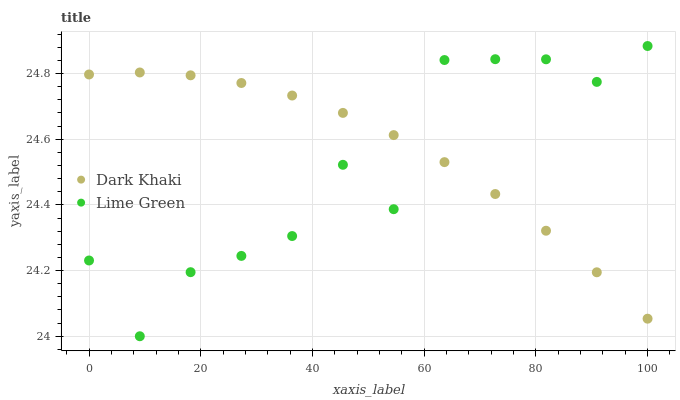Does Lime Green have the minimum area under the curve?
Answer yes or no. Yes. Does Dark Khaki have the maximum area under the curve?
Answer yes or no. Yes. Does Lime Green have the maximum area under the curve?
Answer yes or no. No. Is Dark Khaki the smoothest?
Answer yes or no. Yes. Is Lime Green the roughest?
Answer yes or no. Yes. Is Lime Green the smoothest?
Answer yes or no. No. Does Lime Green have the lowest value?
Answer yes or no. Yes. Does Lime Green have the highest value?
Answer yes or no. Yes. Does Dark Khaki intersect Lime Green?
Answer yes or no. Yes. Is Dark Khaki less than Lime Green?
Answer yes or no. No. Is Dark Khaki greater than Lime Green?
Answer yes or no. No. 